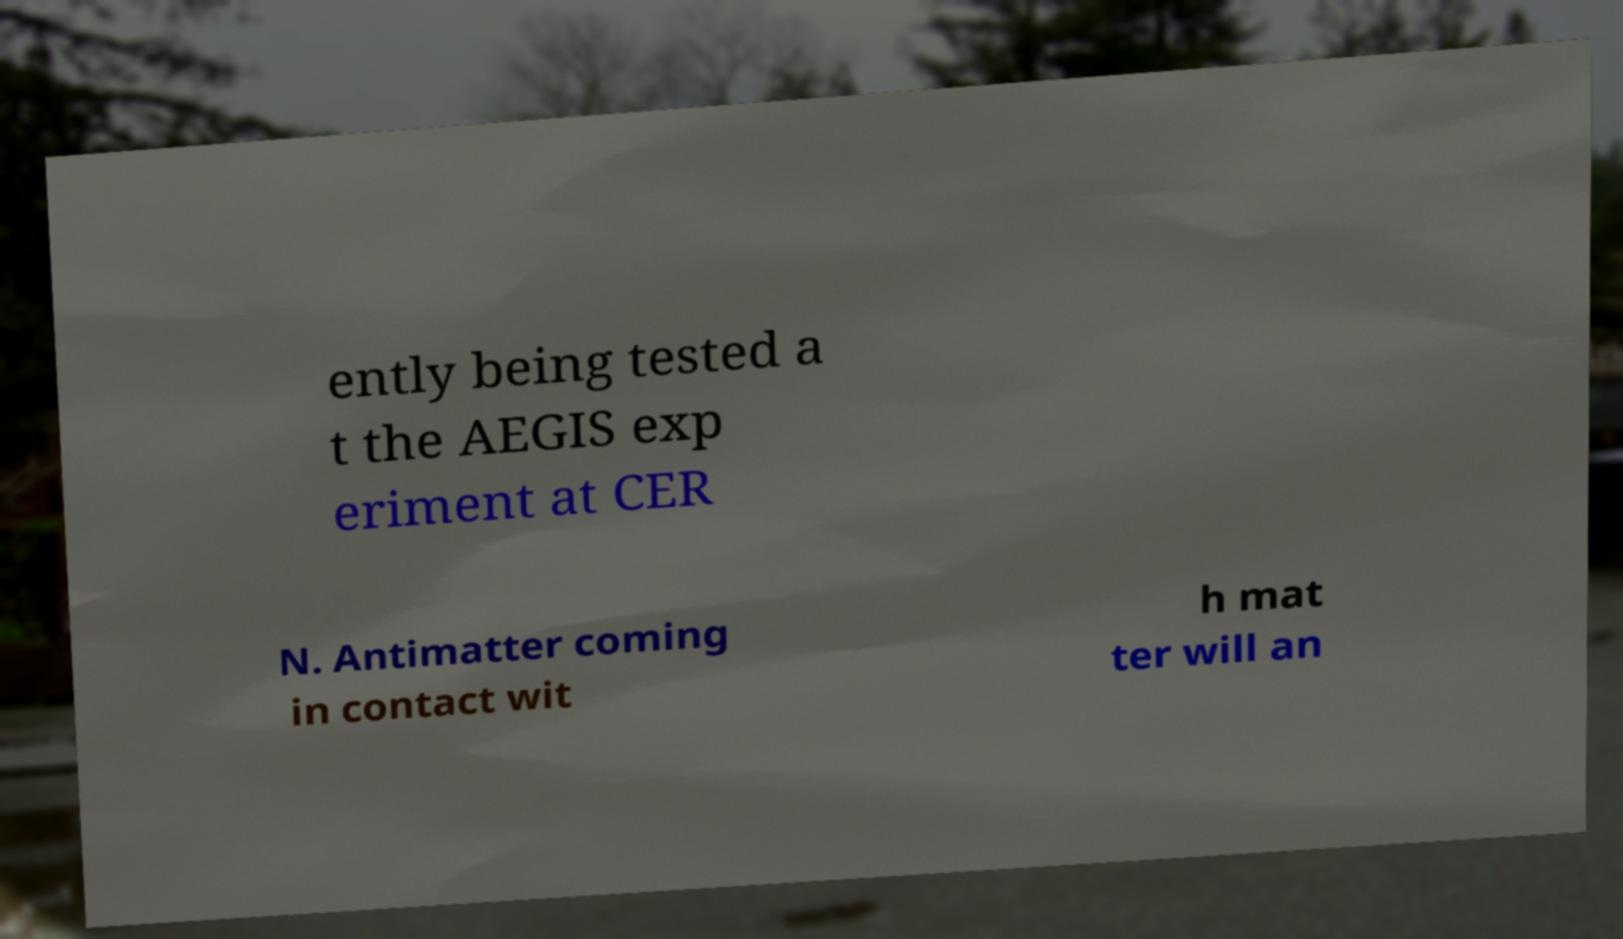There's text embedded in this image that I need extracted. Can you transcribe it verbatim? ently being tested a t the AEGIS exp eriment at CER N. Antimatter coming in contact wit h mat ter will an 